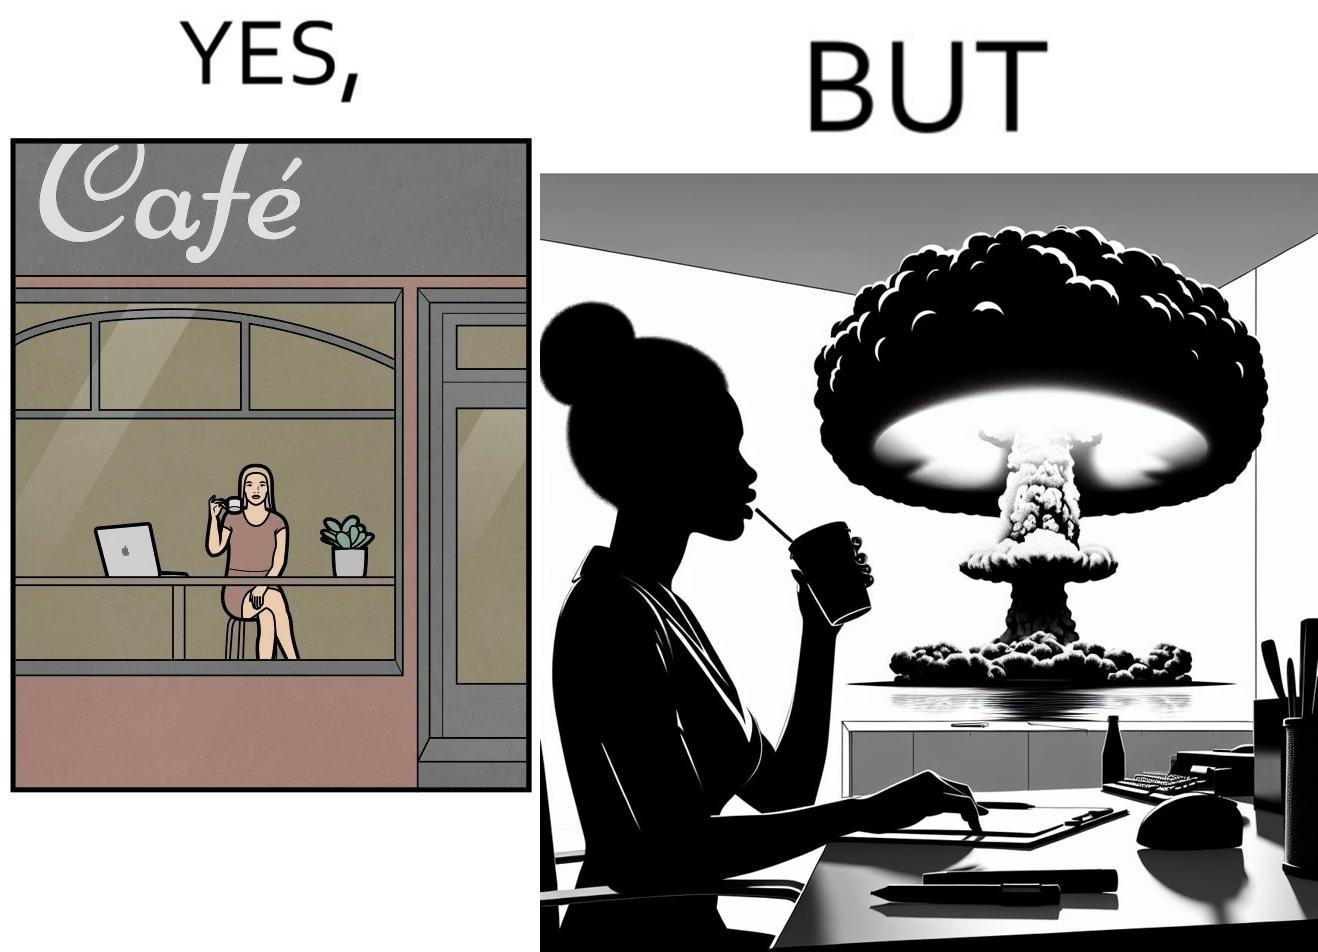What do you see in each half of this image? In the left part of the image: A woman sipping from a cup in a cafe with her laptop In the right part of the image: A woman sipping from a cup while looking at a nuclear blast from her desk 